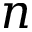Convert formula to latex. <formula><loc_0><loc_0><loc_500><loc_500>n</formula> 